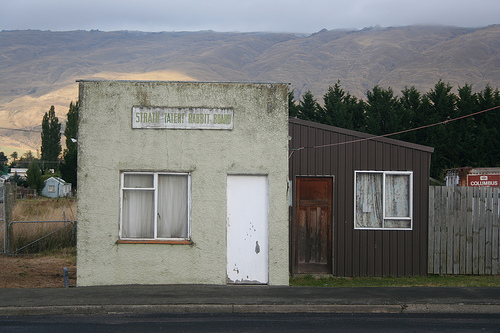<image>
Can you confirm if the mountain is behind the building? Yes. From this viewpoint, the mountain is positioned behind the building, with the building partially or fully occluding the mountain. Is there a window to the left of the house? No. The window is not to the left of the house. From this viewpoint, they have a different horizontal relationship. 